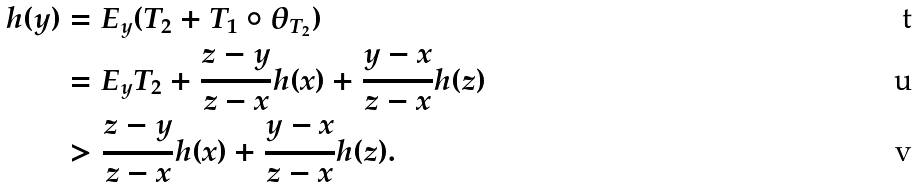Convert formula to latex. <formula><loc_0><loc_0><loc_500><loc_500>h ( y ) & = E _ { y } ( T _ { 2 } + T _ { 1 } \circ \theta _ { T _ { 2 } } ) \\ & = E _ { y } T _ { 2 } + \frac { z - y } { z - x } h ( x ) + \frac { y - x } { z - x } h ( z ) \\ & > \frac { z - y } { z - x } h ( x ) + \frac { y - x } { z - x } h ( z ) .</formula> 